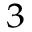Convert formula to latex. <formula><loc_0><loc_0><loc_500><loc_500>^ { 3 }</formula> 